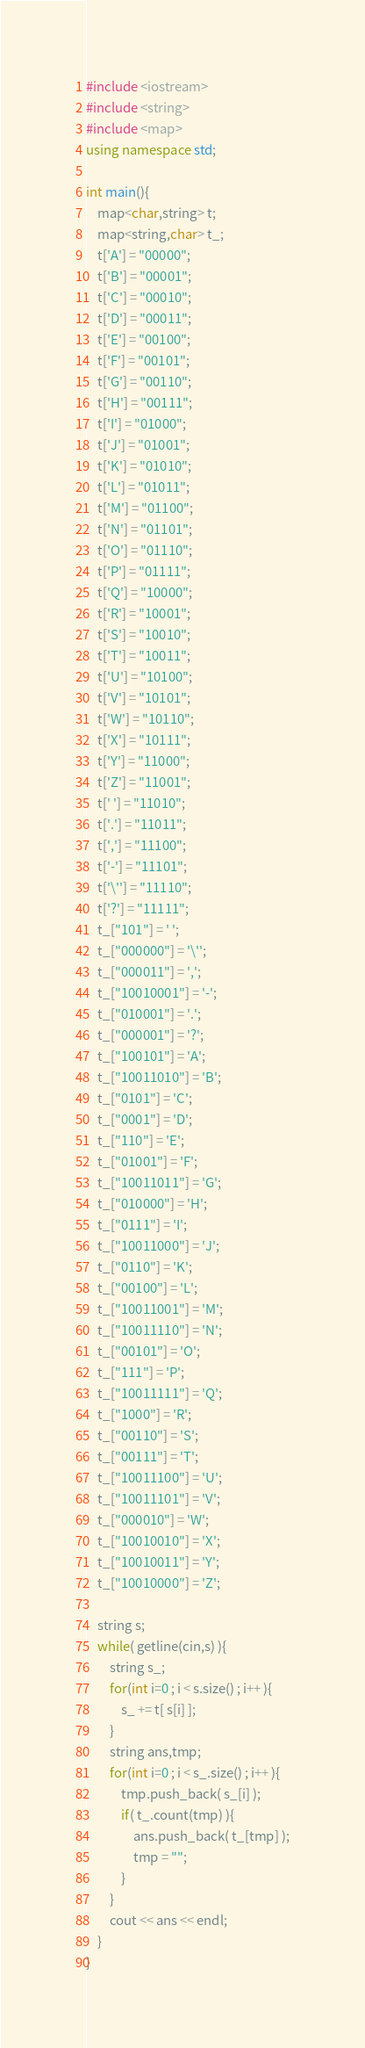Convert code to text. <code><loc_0><loc_0><loc_500><loc_500><_C++_>#include <iostream>
#include <string>
#include <map>
using namespace std;

int main(){
	map<char,string> t;
	map<string,char> t_;
	t['A'] = "00000";
	t['B'] = "00001";
	t['C'] = "00010";
	t['D'] = "00011";
	t['E'] = "00100";
	t['F'] = "00101";
	t['G'] = "00110";
	t['H'] = "00111";
	t['I'] = "01000";
	t['J'] = "01001";
	t['K'] = "01010";
	t['L'] = "01011";
	t['M'] = "01100";
	t['N'] = "01101";
	t['O'] = "01110";
	t['P'] = "01111";
	t['Q'] = "10000";
	t['R'] = "10001";
	t['S'] = "10010";
	t['T'] = "10011";
	t['U'] = "10100";
	t['V'] = "10101";
	t['W'] = "10110";
	t['X'] = "10111";
	t['Y'] = "11000";
	t['Z'] = "11001";
	t[' '] = "11010";
	t['.'] = "11011";
	t[','] = "11100";
	t['-'] = "11101";
	t['\''] = "11110";
	t['?'] = "11111";
	t_["101"] = ' ';
	t_["000000"] = '\'';
	t_["000011"] = ',';
	t_["10010001"] = '-';
	t_["010001"] = '.';
	t_["000001"] = '?';
	t_["100101"] = 'A';
	t_["10011010"] = 'B';
	t_["0101"] = 'C';
	t_["0001"] = 'D';
	t_["110"] = 'E';
	t_["01001"] = 'F';
	t_["10011011"] = 'G';
	t_["010000"] = 'H';
	t_["0111"] = 'I';
	t_["10011000"] = 'J';
	t_["0110"] = 'K';
	t_["00100"] = 'L';
	t_["10011001"] = 'M';
	t_["10011110"] = 'N';
	t_["00101"] = 'O';
	t_["111"] = 'P';
	t_["10011111"] = 'Q';
	t_["1000"] = 'R';
	t_["00110"] = 'S';
	t_["00111"] = 'T';
	t_["10011100"] = 'U';
	t_["10011101"] = 'V';
	t_["000010"] = 'W';
	t_["10010010"] = 'X';
	t_["10010011"] = 'Y';
	t_["10010000"] = 'Z';

	string s;
	while( getline(cin,s) ){
		string s_;
		for(int i=0 ; i < s.size() ; i++ ){
			s_ += t[ s[i] ];
		}
		string ans,tmp;
		for(int i=0 ; i < s_.size() ; i++ ){
			tmp.push_back( s_[i] );
			if( t_.count(tmp) ){
				ans.push_back( t_[tmp] );
				tmp = "";
			}
		}
		cout << ans << endl;
	}
}</code> 